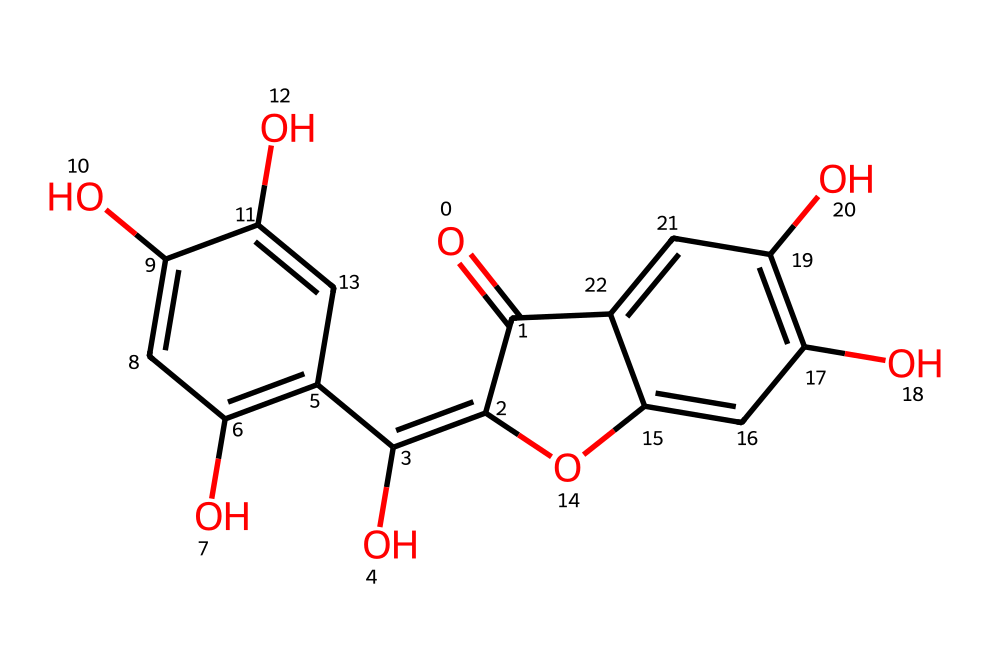How many hydroxyl groups are present in quercetin? The structure reveals three -OH groups attached to the main carbon skeleton, which are essential for its antioxidant properties.
Answer: three What is the molecular formula of quercetin? By counting the number of carbons, hydrogens, and oxygens based on the structure, it can be derived that the molecular formula is C15H10O7.
Answer: C15H10O7 How many rings are in the structure of quercetin? The chemical structure shows two fused benzene rings, indicating the presence of two rings in the entire structure of quercetin.
Answer: two What type of chemical is quercetin classified as? The presence of multiple hydroxyl functional groups and the arrangement of rings suggest that quercetin is a flavonoid, which is a class of plant metabolites known for their antioxidant effects.
Answer: flavonoid What role do the hydroxyl groups play in the activity of quercetin? The hydroxyl groups in quercetin are responsible for donating hydrogen atoms to free radicals, allowing it to function effectively as an antioxidant.
Answer: antioxidant How many carbon atoms does quercetin contain? By analyzing the structure, one can identify that there are a total of 15 carbon atoms present in the quercetin molecule.
Answer: fifteen 